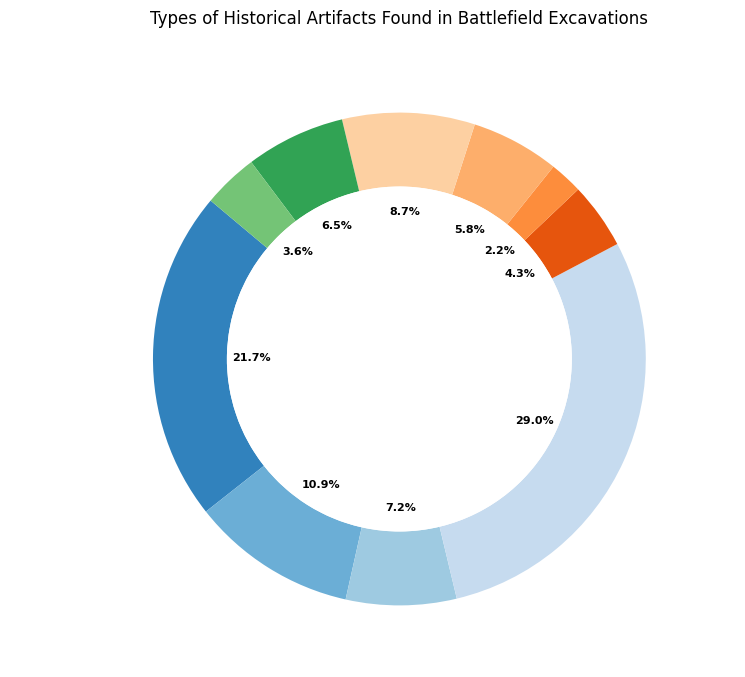What percentage of the artifacts found are weapons? Locate the segment labeled "Weapons" on the ring chart. The percentage value should be written within or near this segment.
Answer: 20% Which category of artifacts has the highest quantity and what is the percentage representation of this category? Locate the largest segment on the ring chart. It is the one labeled "Ammunition." The percentage value written within or near this segment represents its percentage.
Answer: Ammunition, 26.7% What is the combined percentage of "Medical Supplies," "Musical Instruments," and "Tools"? Identify the segments labeled "Medical Supplies," "Musical Instruments," and "Tools" and note their percentages. Sum these percentages: 4% + 2% + 5.3% = 11.3%.
Answer: 11.3% How does the quantity of "Uniform Pieces" compare to the quantity of "Cannonballs"? Locate the segments labeled "Uniform Pieces" and "Cannonballs." Note that the quantity for "Uniform Pieces" is 75, and for "Cannonballs," it is 60. Comparing these two values, 75 > 60.
Answer: Uniform Pieces > Cannonballs Which artifact category contributes more to the total, "Personal Items" or "Miscellaneous Metal Artifacts"? Locate the segments labeled "Personal Items" and "Miscellaneous Metal Artifacts." Note that "Personal Items" has a quantity of 50, and "Miscellaneous Metal Artifacts" has a quantity of 25.
Answer: Personal Items What percentage of artifacts found were either "Buttons" or "Uniform Pieces"? Identify the segments labeled "Buttons" and "Uniform Pieces" and find their respective percentages. Add these percentages: 6% + 10% = 16%.
Answer: 16% What is the average percentage representation of "Personal Items," "Tools," and "Buttons"? Locate the segments labeled "Personal Items," "Tools," and "Buttons." Sum their percentages (6.7% + 5.3% + 6%) and divide by 3: (6.7% + 5.3% + 6%) / 3 = 6%.
Answer: 6% Are "Weapons" more prevalent than "Medical Supplies"? If so, by how much percentage-wise? Locate the segments labeled "Weapons" and "Medical Supplies." Note their percentage values: 20% for "Weapons" and 4% for "Medical Supplies." The difference is 20% - 4% = 16%.
Answer: Yes, by 16% Comparing "Ammunition" and "Cannonballs," what is their combined percentage contribution to the total artifacts found? Identify the segments labeled "Ammunition" and "Cannonballs" and find their percentages. Add these percentages: 26.7% + 8% = 34.7%.
Answer: 34.7% 